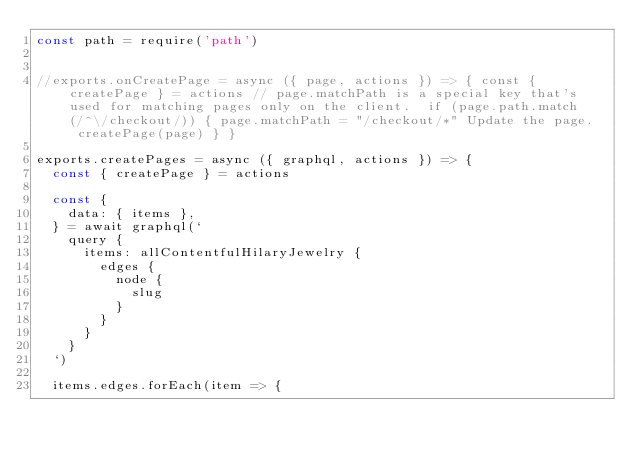<code> <loc_0><loc_0><loc_500><loc_500><_JavaScript_>const path = require('path')


//exports.onCreatePage = async ({ page, actions }) => { const { createPage } = actions // page.matchPath is a special key that's used for matching pages only on the client.  if (page.path.match(/^\/checkout/)) { page.matchPath = "/checkout/*" Update the page.  createPage(page) } }

exports.createPages = async ({ graphql, actions }) => {
  const { createPage } = actions

  const {
    data: { items },
  } = await graphql(`
    query {
      items: allContentfulHilaryJewelry {
        edges {
          node {
            slug
          }
        }
      }
    }
  `)

  items.edges.forEach(item => {</code> 